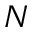Convert formula to latex. <formula><loc_0><loc_0><loc_500><loc_500>N</formula> 